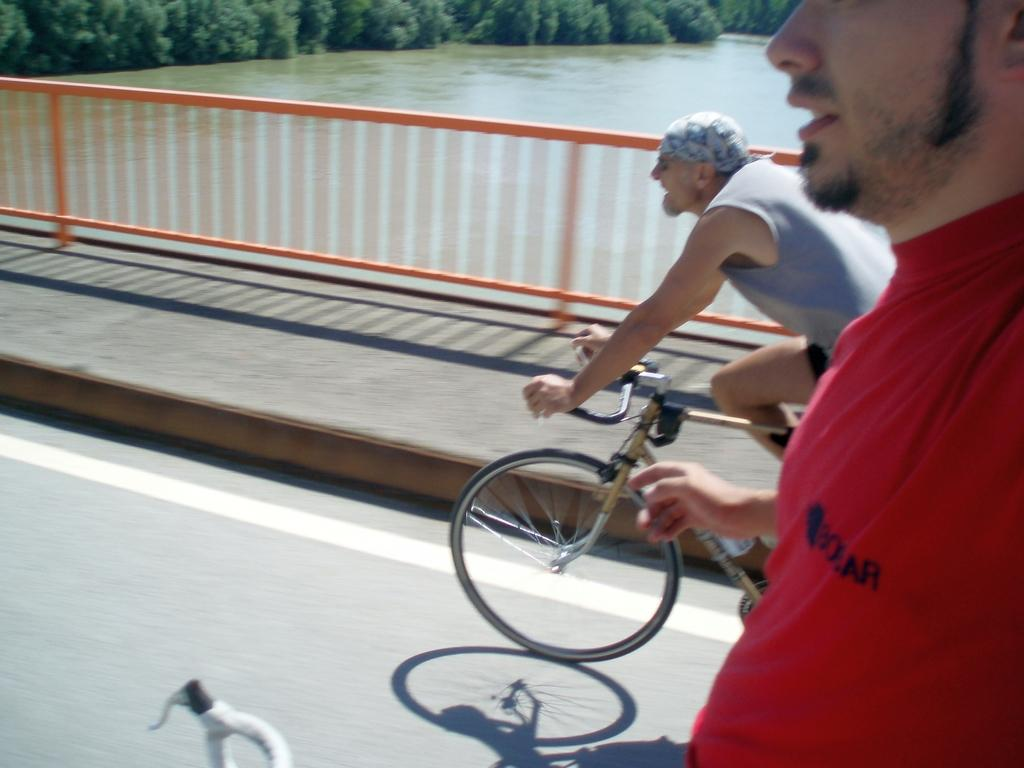How many people are in the image? There are two persons in the image. What are the persons doing in the image? The persons are riding bicycles. Where are the bicycles located? The bicycles are in the street. What can be seen in the background of the image? There is water, a tree, and a bridge visible in the background. What type of peace symbol can be seen hanging from the tree in the image? There is no peace symbol hanging from the tree in the image. What kind of produce is being harvested from the bridge in the image? There is no produce being harvested from the bridge in the image. 